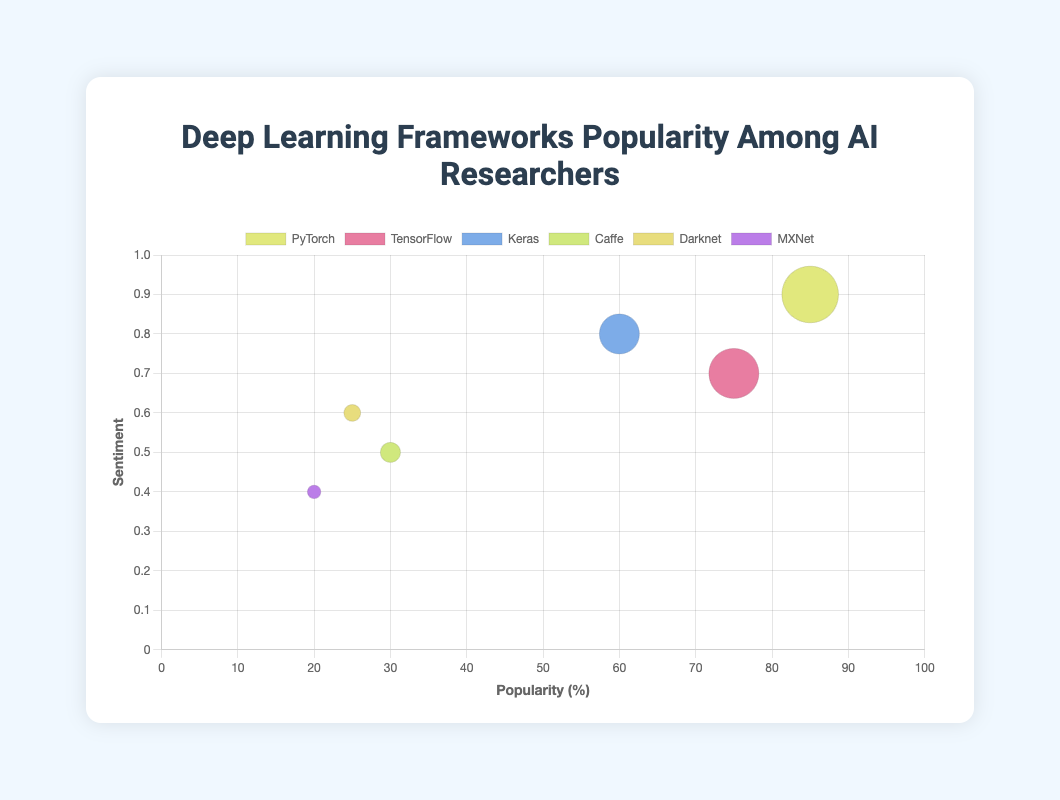What is the most popular deep learning framework among AI researchers? The framework with the highest popularity percentage is the most popular. PyTorch shows a popularity of 85%, which is the highest in the figure.
Answer: PyTorch Among the listed frameworks, which one has the lowest sentiment score? The sentiment score ranges from 0 to 1. MXNet has the lowest sentiment score of 0.4.
Answer: MXNet Which framework has the closest popularity to TensorFlow? TensorFlow has a popularity of 75%. The framework closest to this value is Keras with a popularity of 60%.
Answer: Keras What is the combined popularity of Darknet and Caffe? Adding the popularity percentages of Darknet (25%) and Caffe (30%) gives 25 + 30.
Answer: 55% Which framework has a higher sentiment score, Keras or Darknet? Keras and Darknet have sentiment scores of 0.8 and 0.6, respectively. Since 0.8 is greater than 0.6, Keras has a higher sentiment score.
Answer: Keras How does the popularity of MXNet compare to that of Caffe? MXNet has a popularity of 20% while Caffe has a popularity of 30%. Since 20% is less than 30%, MXNet is less popular than Caffe.
Answer: MXNet is less popular Which framework is represented by the rocket emoji 🚀? The chart's tooltips would indicate that TensorFlow is represented by the rocket emoji 🚀.
Answer: TensorFlow If we only consider frameworks with a sentiment score above 0.7, how many are there? Frameworks with sentiment scores above 0.7 are PyTorch (0.9), TensorFlow (0.7 exactly, not above), and Keras (0.8). Only PyTorch and Keras satisfy the condition.
Answer: 2 